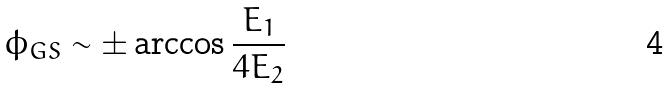Convert formula to latex. <formula><loc_0><loc_0><loc_500><loc_500>\phi _ { G S } \sim \pm \arccos \frac { E _ { 1 } } { 4 E _ { 2 } }</formula> 